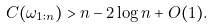<formula> <loc_0><loc_0><loc_500><loc_500>C ( \omega _ { 1 \colon n } ) > n - 2 \log n + O ( 1 ) .</formula> 